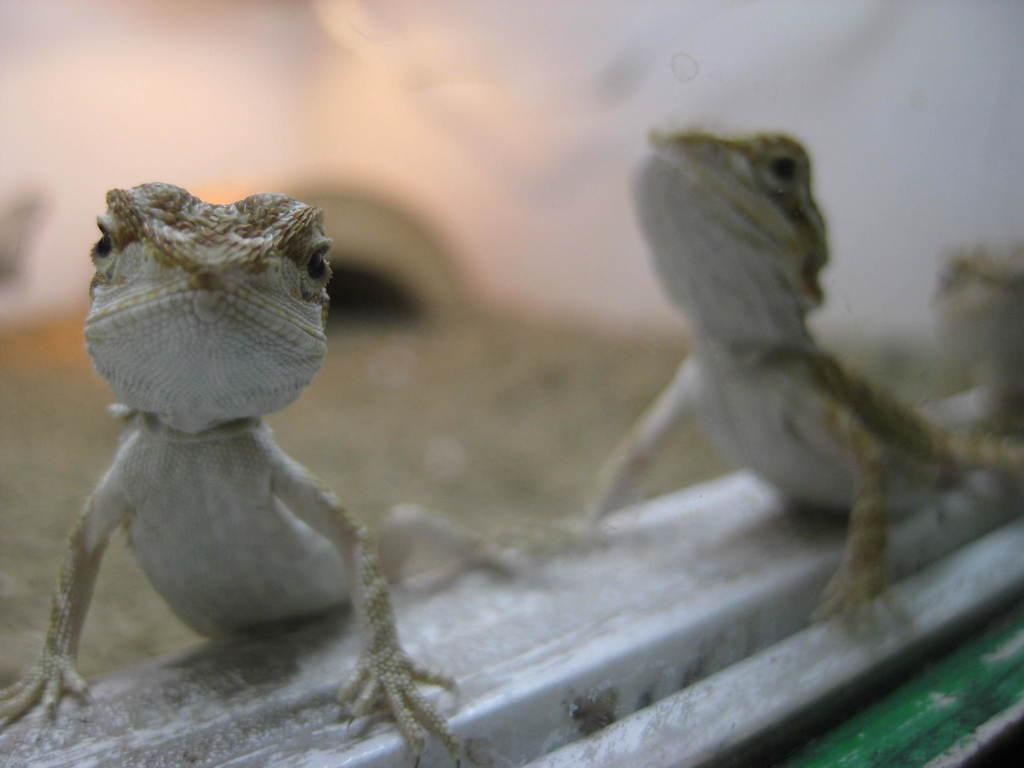What type of animals are present in the image? There are lizards in the image. Can you describe the background of the image? The background of the image is blurred. How does the toad contribute to the quiet atmosphere in the image? There is no toad present in the image, so it cannot contribute to the atmosphere. 